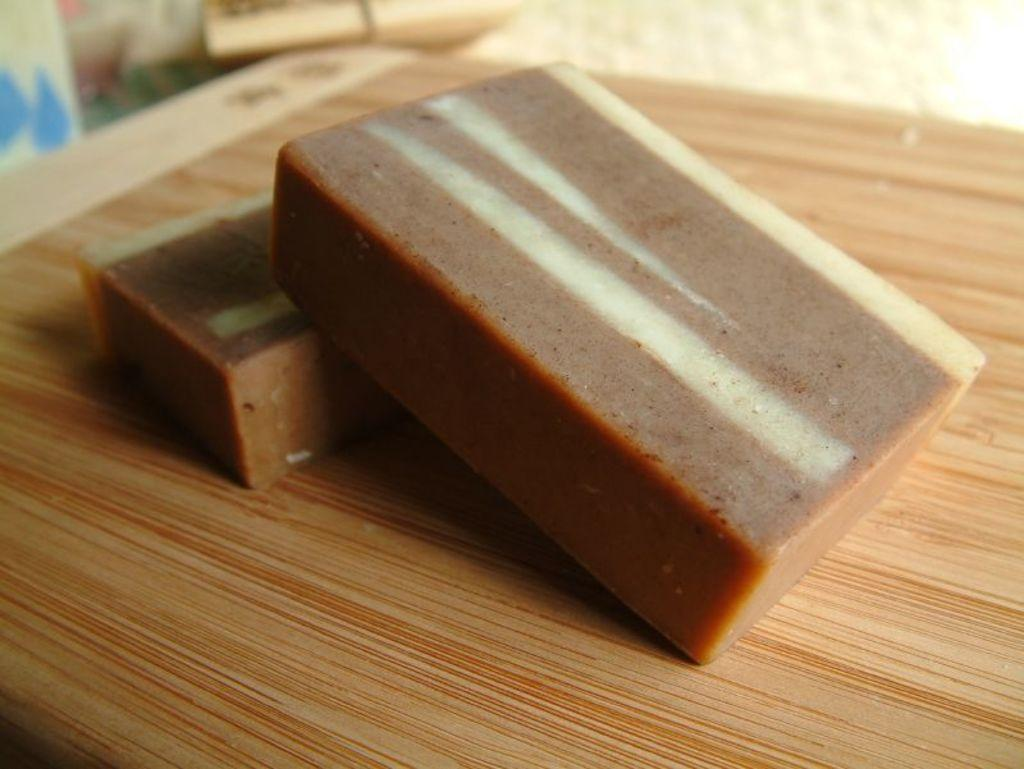What is the main subject of the image? There is a food item in the image. What is the color of the table on which the food item is placed? The food item is on a brown table. What colors are used to depict the food item? The food is in brown and cream colors. What shape is the potato in the image? There is no potato present in the image, so we cannot determine its shape. What type of square food item can be seen in the image? There is no square food item present in the image. 